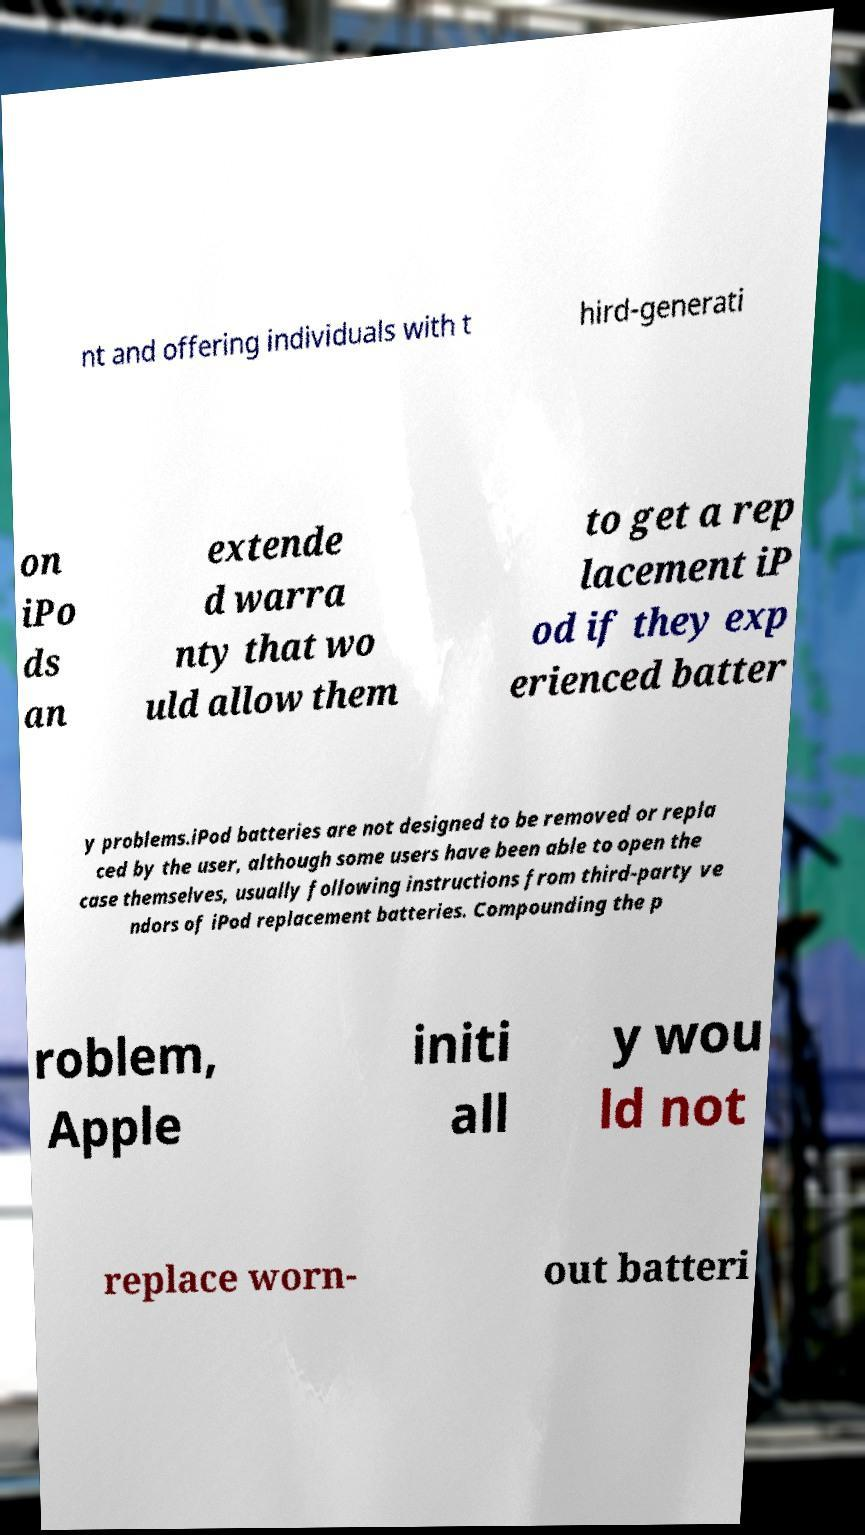Can you accurately transcribe the text from the provided image for me? nt and offering individuals with t hird-generati on iPo ds an extende d warra nty that wo uld allow them to get a rep lacement iP od if they exp erienced batter y problems.iPod batteries are not designed to be removed or repla ced by the user, although some users have been able to open the case themselves, usually following instructions from third-party ve ndors of iPod replacement batteries. Compounding the p roblem, Apple initi all y wou ld not replace worn- out batteri 